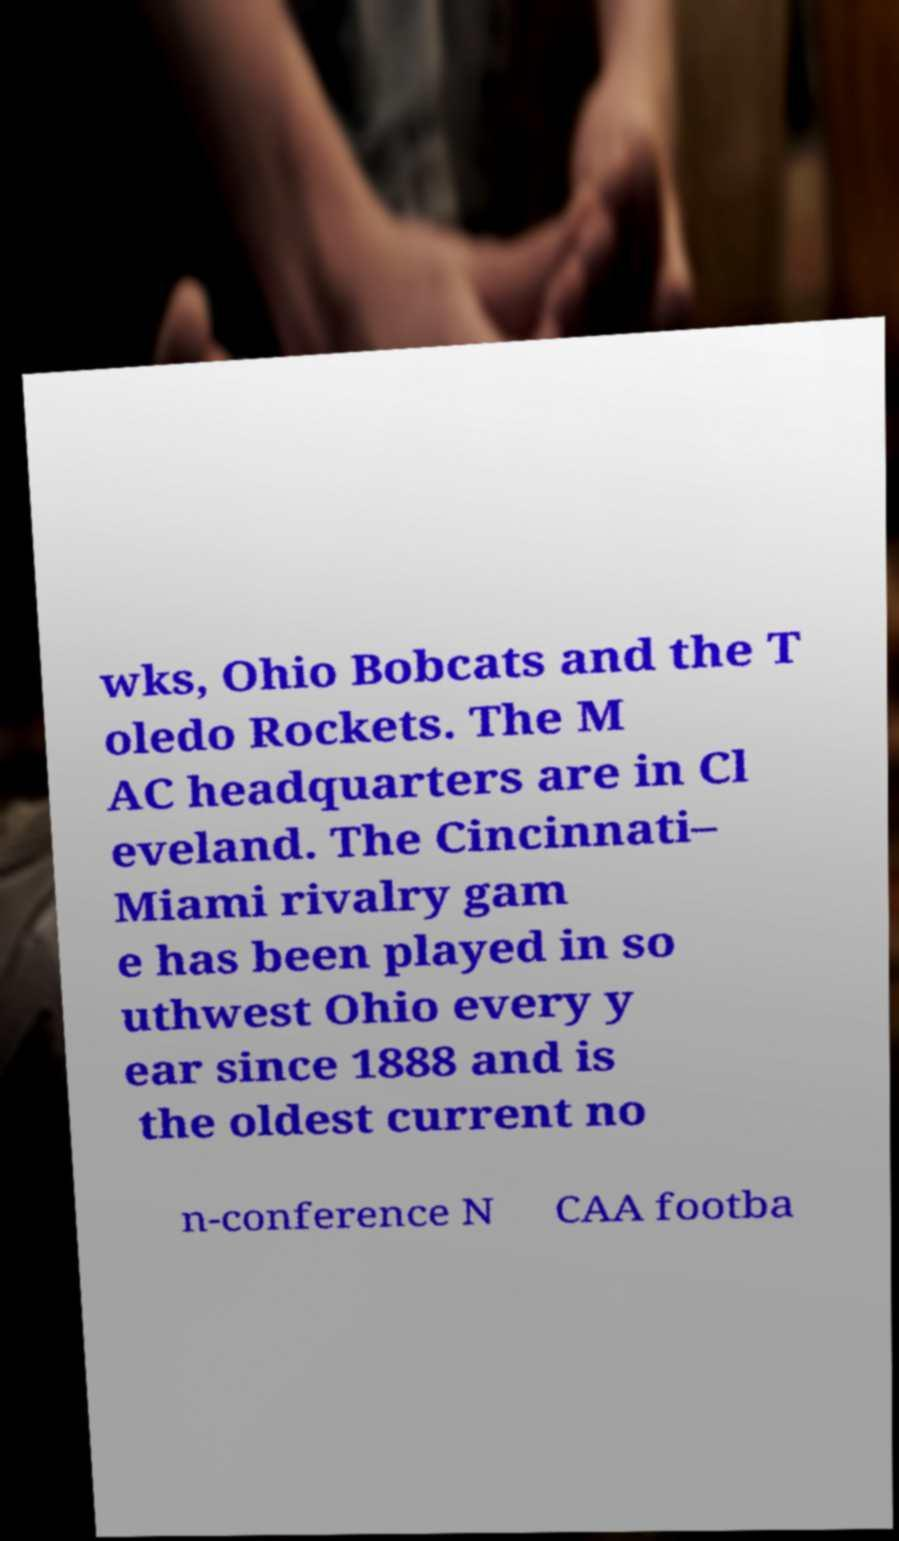There's text embedded in this image that I need extracted. Can you transcribe it verbatim? wks, Ohio Bobcats and the T oledo Rockets. The M AC headquarters are in Cl eveland. The Cincinnati– Miami rivalry gam e has been played in so uthwest Ohio every y ear since 1888 and is the oldest current no n-conference N CAA footba 